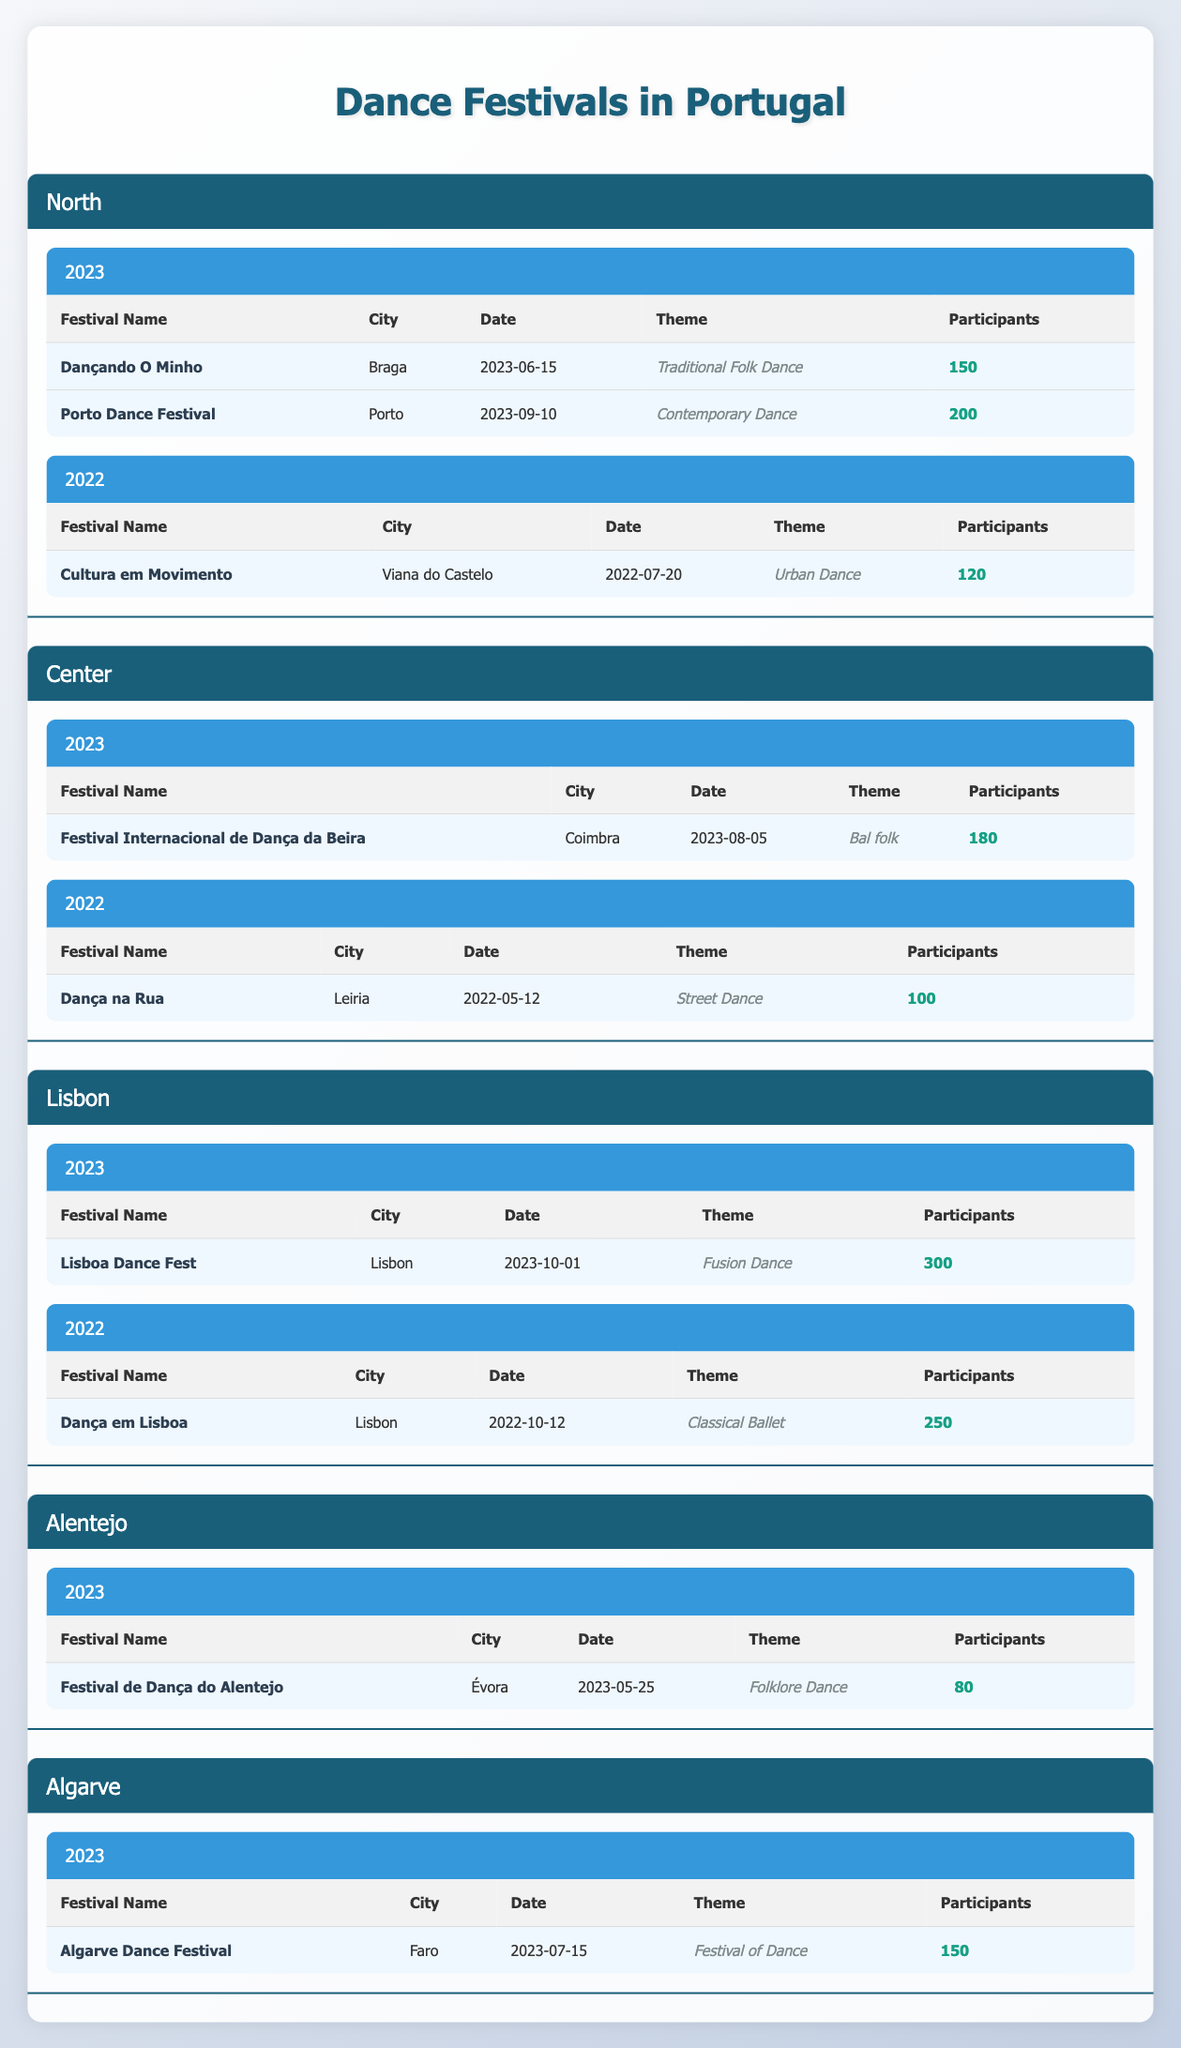What is the total number of participants in dance festivals in the North region for 2023? In the Northern region, there are two festivals in 2023: Dançando O Minho with 150 participants and Porto Dance Festival with 200 participants. To find the total, we sum these participants: 150 + 200 = 350.
Answer: 350 Which dance festival in Lisbon had the highest number of participants in 2022? In Lisbon in 2022, there are two festivals: Dança em Lisboa with 250 participants and Lisboa Dance Fest is not included for this year. Hence, the highest number of participants is from Dança em Lisboa, which had 250 participants.
Answer: 250 Did the Alentejo region have any dance festivals in 2022? The table shows that there is no entry listed for Alentejo in 2022, indicating that there were no dance festivals held in that region for that year.
Answer: No What is the average number of participants across all dance festivals in the Algarve region for 2023? There is one festival in the Algarve region for 2023, which is the Algarve Dance Festival with 150 participants. Since there's only one festival, the average is simply 150 divided by 1, which is 150.
Answer: 150 Which year had more dance festivals in the North region: 2022 or 2023? In 2022, the North region had one festival called Cultura em Movimento, while in 2023, there are two festivals: Dançando O Minho and Porto Dance Festival. Therefore, 2023 had more festivals.
Answer: 2023 What was the theme of the Festival Internacional de Dança da Beira in 2023? Referencing the table, the Festival Internacional de Dança da Beira, held in Coimbra in 2023, has the theme "Bal folk."
Answer: Bal folk How many total dance festivals took place in Portugal across all regions in 2023? After reviewing the data, in 2023, the North had 2 festivals, the Center had 1 festival, Lisbon had 1 festival, Alentejo had 1, and Algarve had 1. Summing these gives us a total of 2 + 1 + 1 + 1 + 1 = 6 festivals in total.
Answer: 6 Is the number of participants in the Lisboa Dance Fest greater than those in the combined North festivals in 2023? The Lisboa Dance Fest has 300 participants. The North region's total participants in 2023 (350) does exceed this number. Thus, the number of participants in the Lisboa Dance Fest is not greater.
Answer: No Which festival had the earliest date in 2022 and what was the city? Referring to the table, the earliest date in 2022 is May 12 for the festival Dança na Rua, which took place in Leiria.
Answer: Dança na Rua, Leiria 